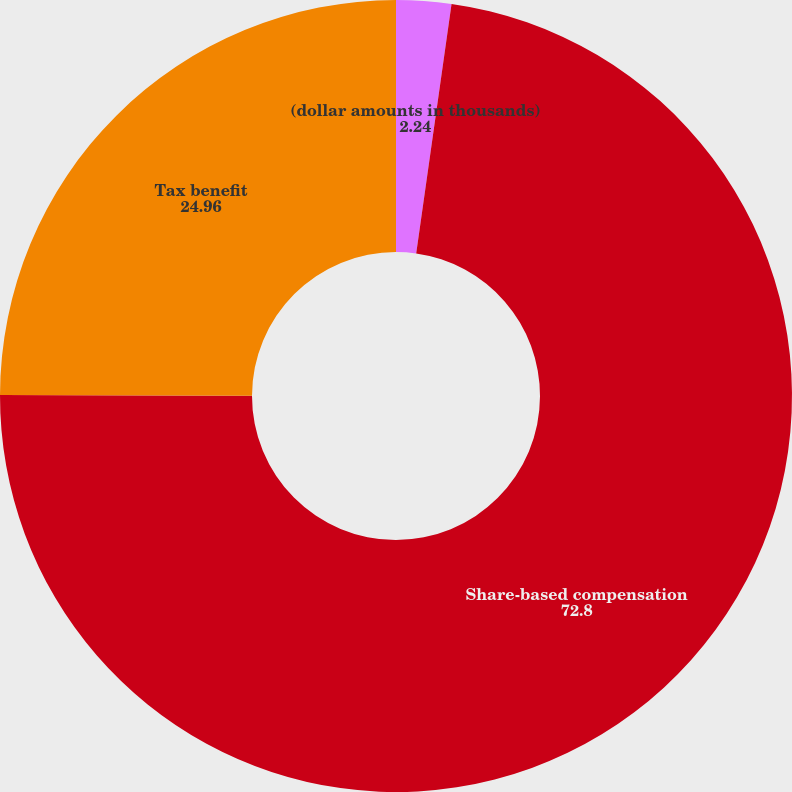Convert chart. <chart><loc_0><loc_0><loc_500><loc_500><pie_chart><fcel>(dollar amounts in thousands)<fcel>Share-based compensation<fcel>Tax benefit<nl><fcel>2.24%<fcel>72.8%<fcel>24.96%<nl></chart> 